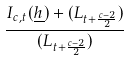<formula> <loc_0><loc_0><loc_500><loc_500>\frac { I _ { c , t } ( \underline { h } ) + ( L _ { t + \frac { c - 2 } { 2 } } ) } { ( L _ { t + \frac { c - 2 } { 2 } } ) }</formula> 